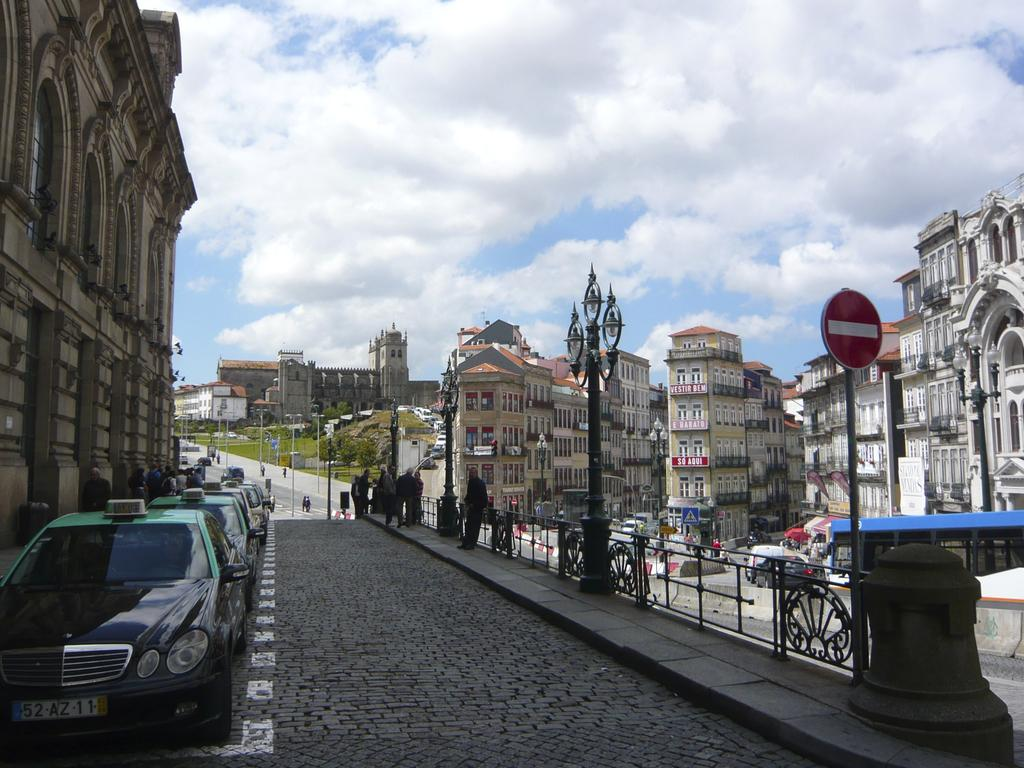What is the main feature in the middle of the image? There is a road in the middle of the image. What is happening on the road? There are vehicles on the road and people walking on the road. What can be seen on either side of the road? There are buildings on either side of the road. What is visible above the road and buildings? The sky is visible in the image, and there are clouds in the sky. What type of hand can be seen holding a face in the image? There is no hand or face present in the image. What is the income of the person driving the vehicle in the image? There is no information about the income of the person driving the vehicle in the image. 